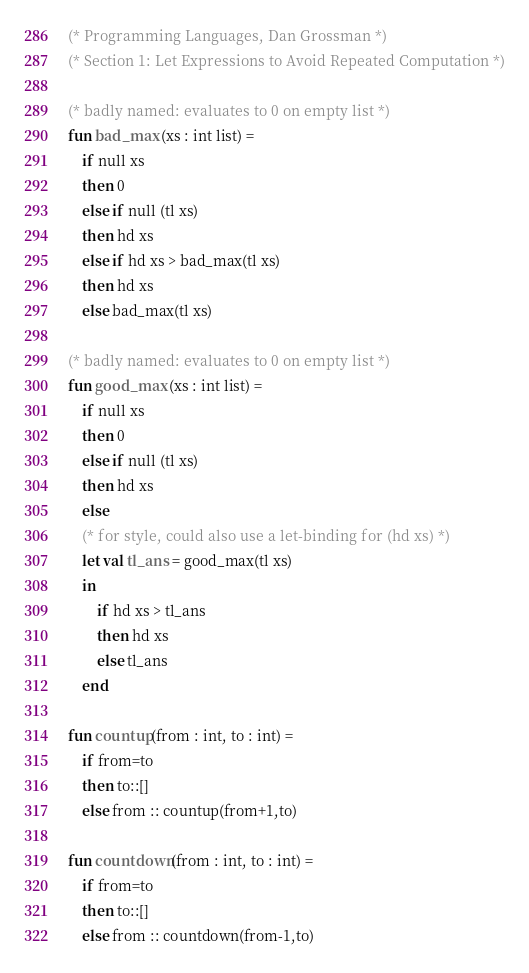<code> <loc_0><loc_0><loc_500><loc_500><_SML_>(* Programming Languages, Dan Grossman *)
(* Section 1: Let Expressions to Avoid Repeated Computation *)

(* badly named: evaluates to 0 on empty list *)
fun bad_max (xs : int list) =
    if null xs
    then 0
    else if null (tl xs)
    then hd xs
    else if hd xs > bad_max(tl xs)
    then hd xs
    else bad_max(tl xs)

(* badly named: evaluates to 0 on empty list *)
fun good_max (xs : int list) =
    if null xs
    then 0
    else if null (tl xs)
    then hd xs
    else
	(* for style, could also use a let-binding for (hd xs) *)
	let val tl_ans = good_max(tl xs)
	in
	    if hd xs > tl_ans
	    then hd xs
	    else tl_ans
	end

fun countup(from : int, to : int) =
    if from=to
    then to::[]
    else from :: countup(from+1,to)

fun countdown(from : int, to : int) =
    if from=to
    then to::[]
    else from :: countdown(from-1,to)

</code> 